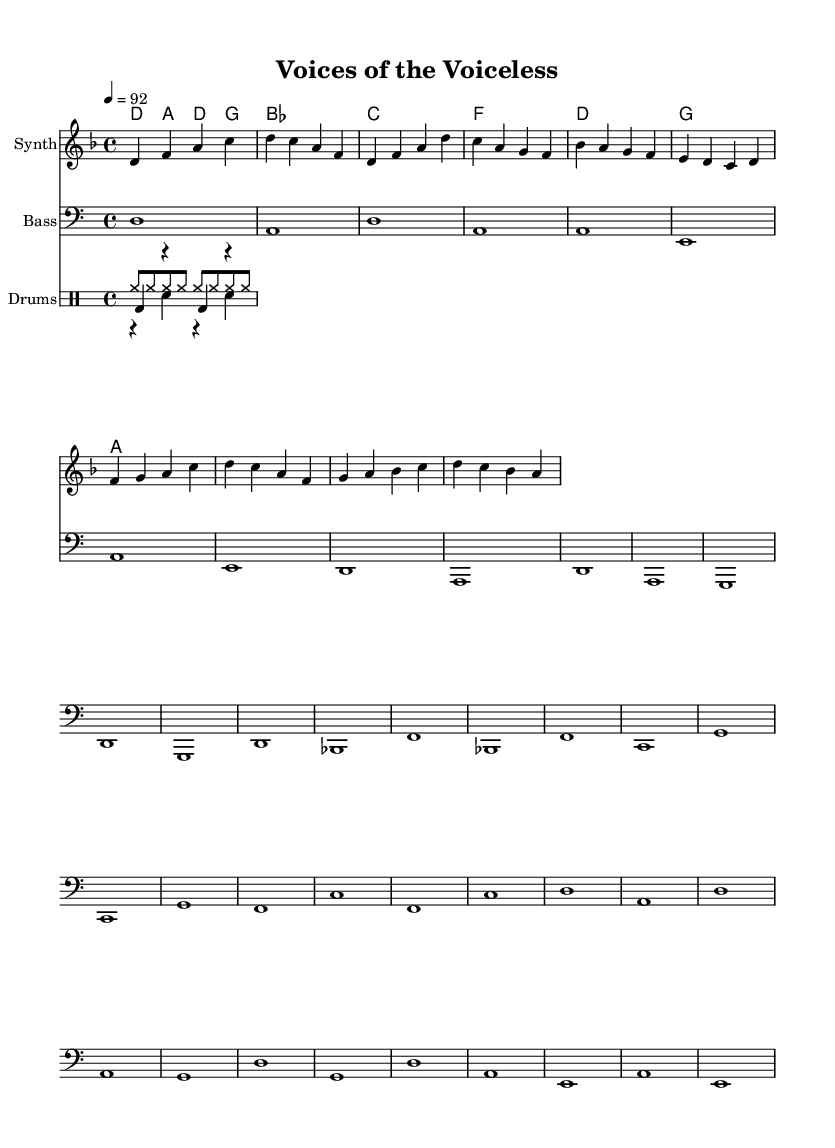What is the key signature of this music? The key signature is D minor, which includes one flat (B flat) in the scale.
Answer: D minor What is the time signature of this music? The time signature is indicated as 4/4, meaning there are four beats per measure and the quarter note gets one beat.
Answer: 4/4 What is the tempo of the piece? The tempo marking shows 4 = 92, indicating there are 92 beats per minute, and the quarter note is the note counted.
Answer: 92 How many measures are in the intro section? The intro section consists of two measures, as indicated by the music notation before the verse starts.
Answer: 2 What type of ensemble is this music written for? The music is written for a combination of synthesizer, bass, and drums, which is typical in rap music for rhythmic and harmonic support.
Answer: Synthesizer, bass, and drums What is the primary theme explored in the lyrics of the rap? The main theme focuses on the ethical treatment of farm animals, highlighting their plight and promoting animal rights through conscious rap.
Answer: Ethical treatment of farm animals What is the main rhythmic pattern used in the drum section? The drum section features a consistent kick drum, snare, and hi-hat pattern, characteristic of the hip-hop style which supports the flow of rap lyrics.
Answer: Kick, snare, and hi-hat pattern 